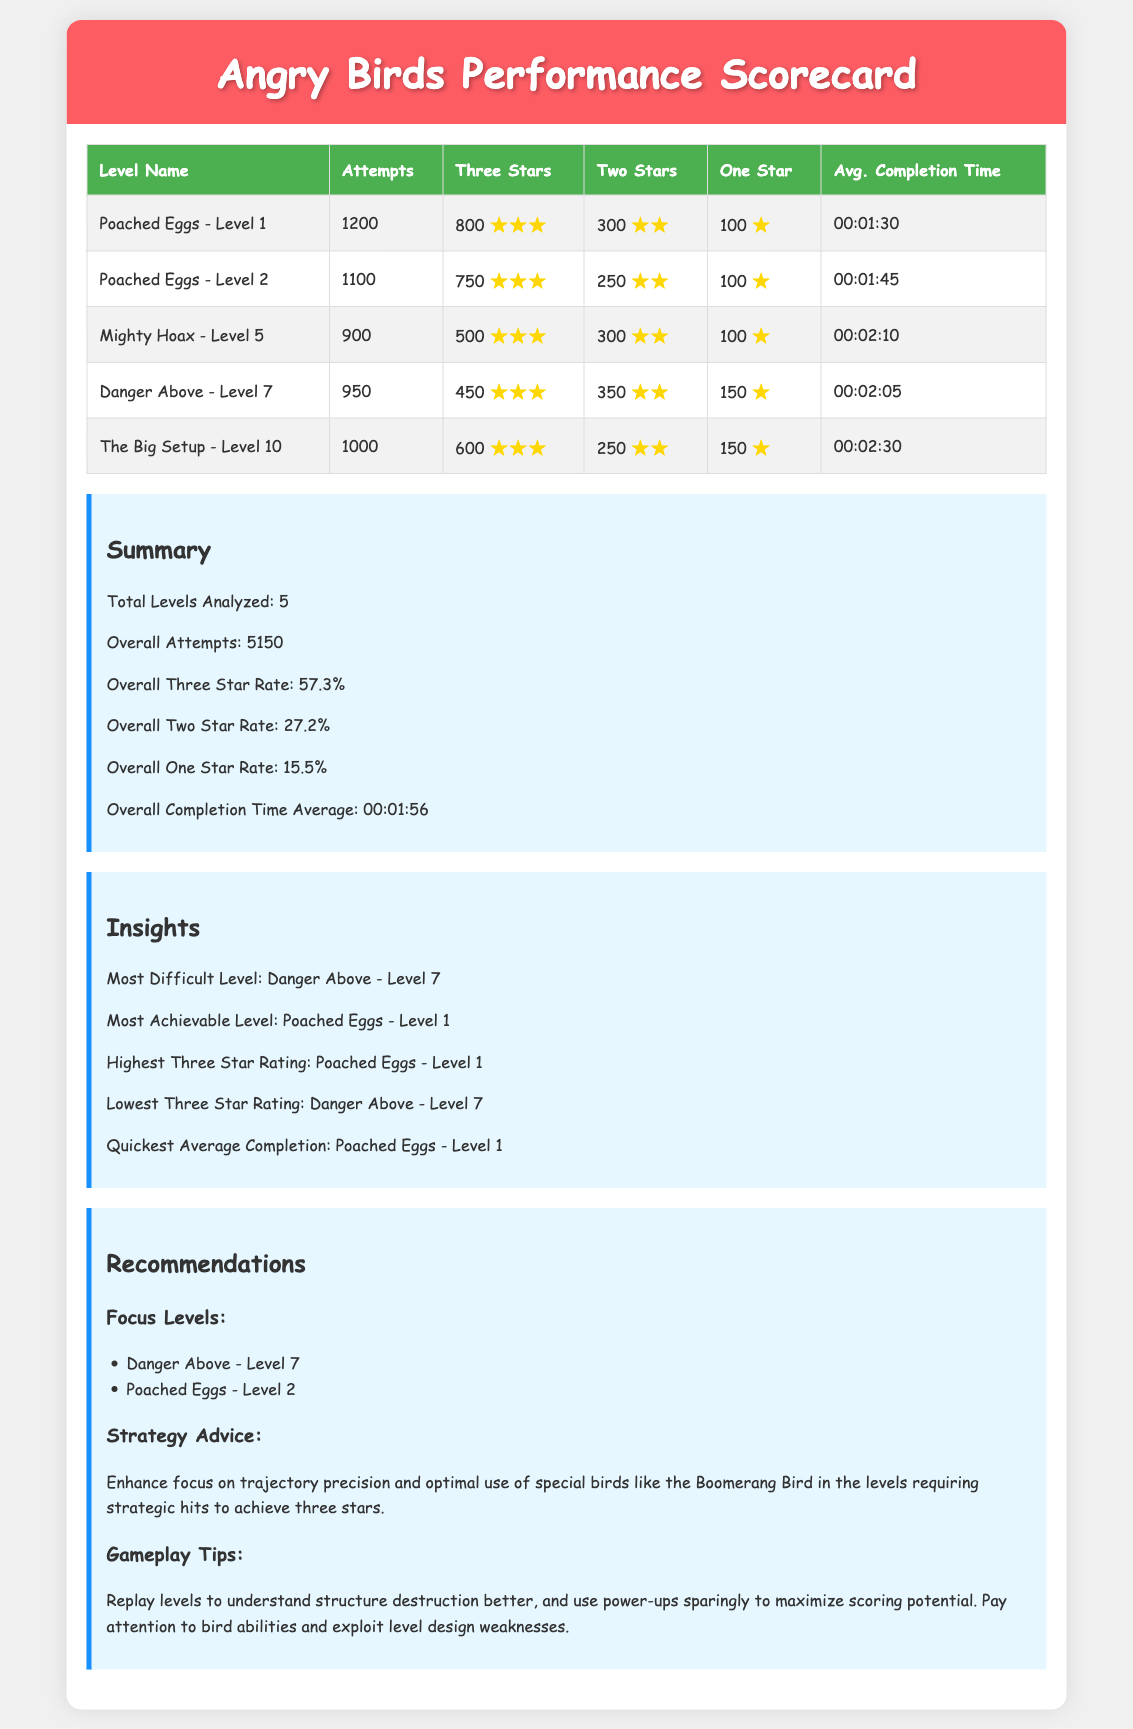What is the total number of levels analyzed? The document states that a total of 5 levels were analyzed.
Answer: 5 What is the overall three star rate? The overall three star rate is provided in the summary section of the document as a percentage of successful attempts.
Answer: 57.3% Which level had the highest number of attempts? By comparing the attempts listed for each level, the level with the highest number of attempts is identified.
Answer: Poached Eggs - Level 1 What is the quickest average completion time? The average completion times are listed for each level, and the quickest one is indicated in the summary.
Answer: 00:01:30 Which level is considered the most difficult? The insights section specifies the level that is deemed the most challenging based on performance metrics.
Answer: Danger Above - Level 7 How many attempts did "Mighty Hoax - Level 5" have? Referring to the table, the number of attempts for that specific level can be directly extracted.
Answer: 900 What is the lowest three star rating achieved? By looking at the three star ratings across all levels, the document identifies the level with the lowest rate.
Answer: Danger Above - Level 7 What is one recommendation for strategy advice? The recommendations section provides strategic advice on gameplay, which can be directly quoted.
Answer: Enhance focus on trajectory precision What is the average completion time across all levels? The overall average completion time is listed in the summary section of the document.
Answer: 00:01:56 